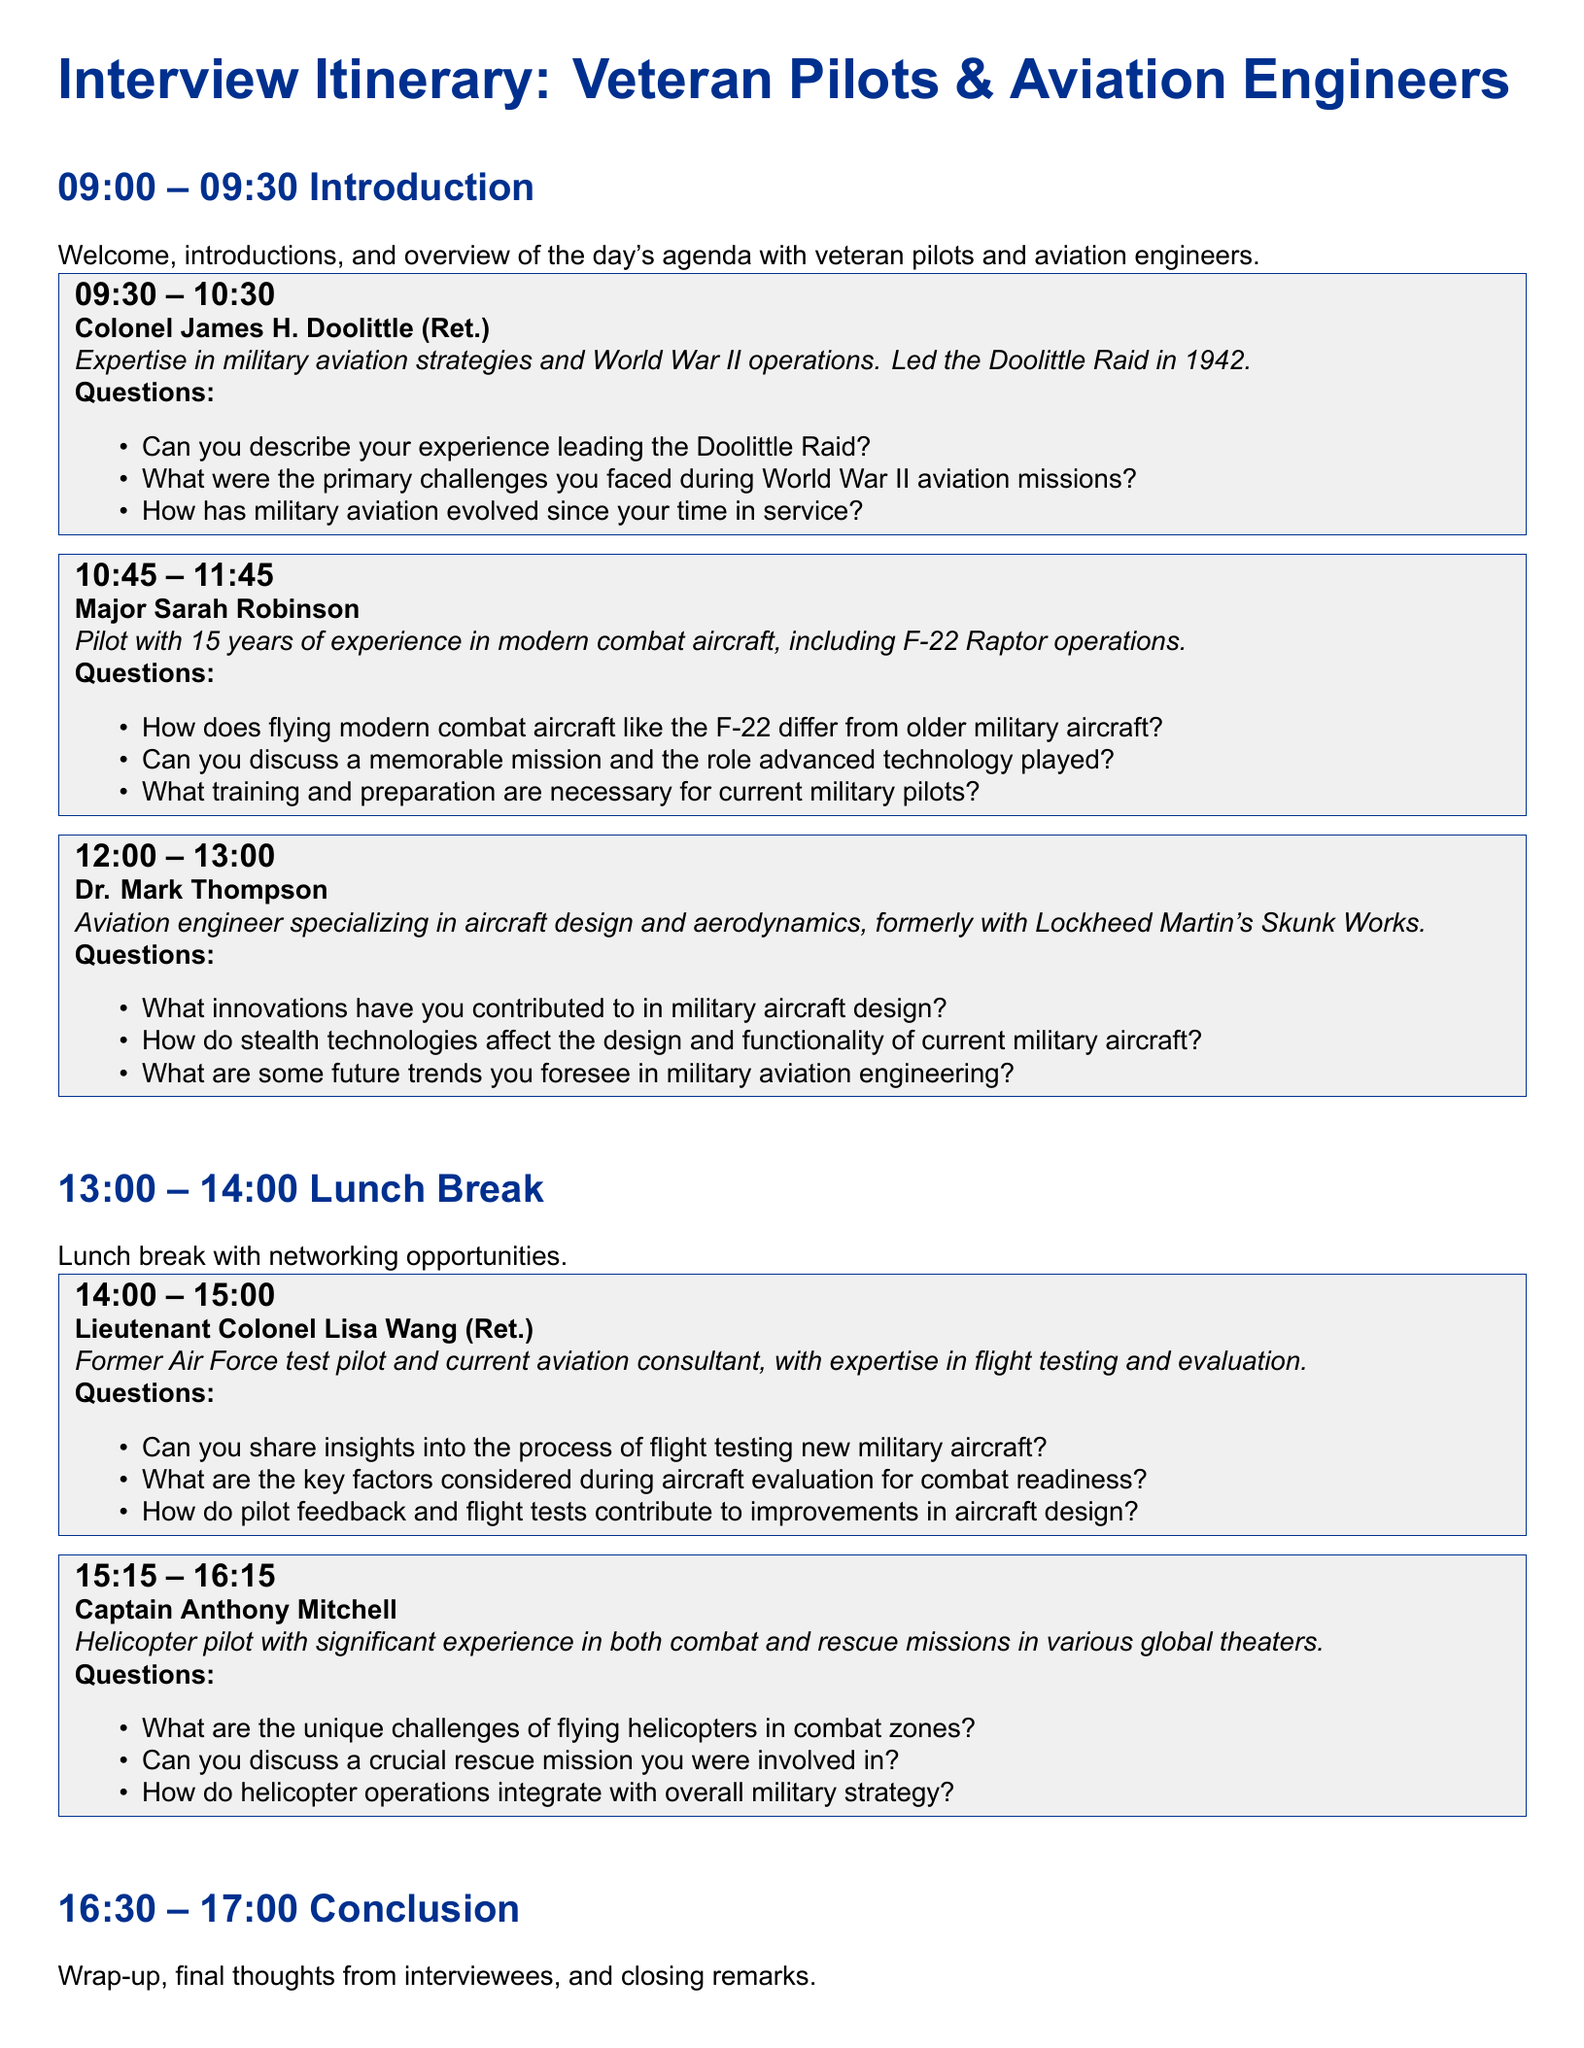What is the date and time for the introduction? The introduction is scheduled for 09:00 -- 09:30.
Answer: 09:00 -- 09:30 Who is the first interview subject? The first interview subject listed is Colonel James H. Doolittle (Ret.).
Answer: Colonel James H. Doolittle (Ret.) How long is the lunch break scheduled? The lunch break is scheduled from 13:00 to 14:00, making it one hour long.
Answer: 1 hour What is Major Sarah Robinson's expertise in? Major Sarah Robinson has expertise in modern combat aircraft.
Answer: modern combat aircraft How many questions are prepared for Dr. Mark Thompson's interview? There are three questions prepared for Dr. Mark Thompson's interview.
Answer: 3 questions What is the focus of Lieutenant Colonel Lisa Wang's expertise? Lieutenant Colonel Lisa Wang's expertise focuses on flight testing and evaluation.
Answer: flight testing and evaluation What role did Colonel James H. Doolittle play in an important historical military event? He led the Doolittle Raid in 1942.
Answer: Doolittle Raid What time does Captain Anthony Mitchell's interview start? Captain Anthony Mitchell's interview starts at 15:15.
Answer: 15:15 